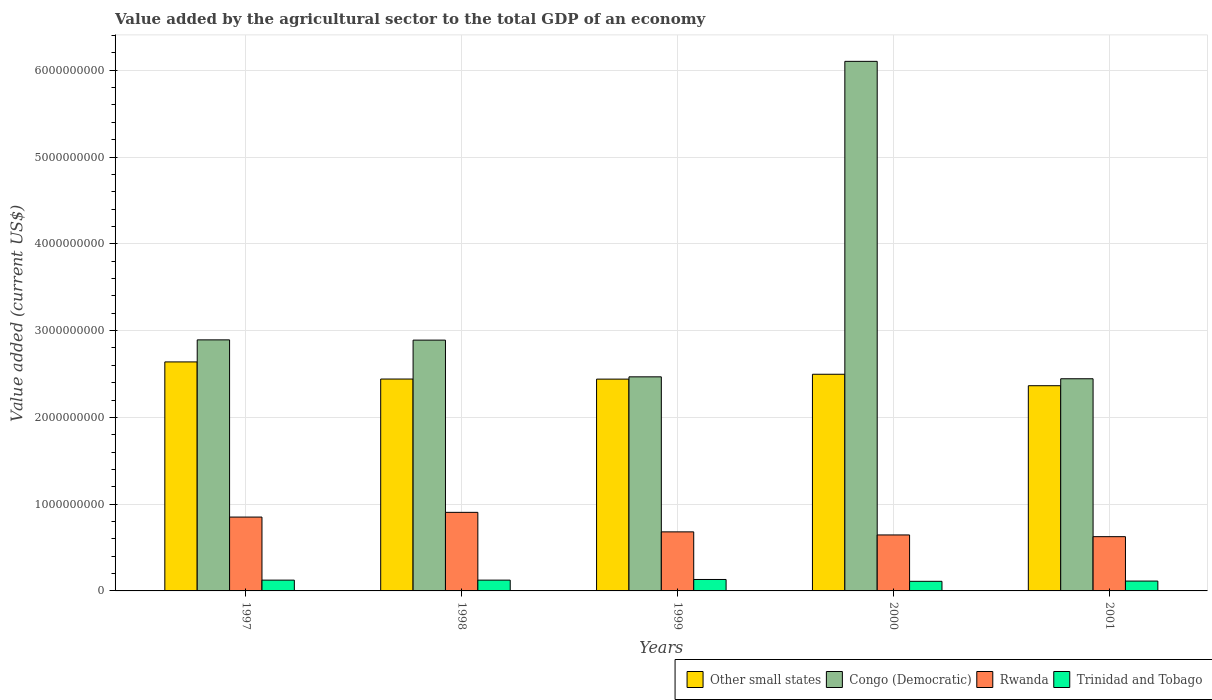How many groups of bars are there?
Offer a terse response. 5. Are the number of bars on each tick of the X-axis equal?
Your response must be concise. Yes. How many bars are there on the 3rd tick from the left?
Your response must be concise. 4. How many bars are there on the 4th tick from the right?
Keep it short and to the point. 4. What is the label of the 1st group of bars from the left?
Your response must be concise. 1997. In how many cases, is the number of bars for a given year not equal to the number of legend labels?
Make the answer very short. 0. What is the value added by the agricultural sector to the total GDP in Congo (Democratic) in 1997?
Your answer should be very brief. 2.89e+09. Across all years, what is the maximum value added by the agricultural sector to the total GDP in Congo (Democratic)?
Your response must be concise. 6.10e+09. Across all years, what is the minimum value added by the agricultural sector to the total GDP in Other small states?
Offer a terse response. 2.36e+09. In which year was the value added by the agricultural sector to the total GDP in Other small states maximum?
Keep it short and to the point. 1997. In which year was the value added by the agricultural sector to the total GDP in Congo (Democratic) minimum?
Your answer should be very brief. 2001. What is the total value added by the agricultural sector to the total GDP in Congo (Democratic) in the graph?
Provide a succinct answer. 1.68e+1. What is the difference between the value added by the agricultural sector to the total GDP in Trinidad and Tobago in 1998 and that in 2001?
Offer a very short reply. 1.09e+07. What is the difference between the value added by the agricultural sector to the total GDP in Trinidad and Tobago in 1998 and the value added by the agricultural sector to the total GDP in Other small states in 2001?
Offer a very short reply. -2.24e+09. What is the average value added by the agricultural sector to the total GDP in Congo (Democratic) per year?
Make the answer very short. 3.36e+09. In the year 1999, what is the difference between the value added by the agricultural sector to the total GDP in Trinidad and Tobago and value added by the agricultural sector to the total GDP in Other small states?
Ensure brevity in your answer.  -2.31e+09. In how many years, is the value added by the agricultural sector to the total GDP in Other small states greater than 1800000000 US$?
Your response must be concise. 5. What is the ratio of the value added by the agricultural sector to the total GDP in Congo (Democratic) in 1997 to that in 2000?
Your answer should be compact. 0.47. Is the difference between the value added by the agricultural sector to the total GDP in Trinidad and Tobago in 1997 and 1999 greater than the difference between the value added by the agricultural sector to the total GDP in Other small states in 1997 and 1999?
Offer a terse response. No. What is the difference between the highest and the second highest value added by the agricultural sector to the total GDP in Congo (Democratic)?
Ensure brevity in your answer.  3.21e+09. What is the difference between the highest and the lowest value added by the agricultural sector to the total GDP in Rwanda?
Provide a short and direct response. 2.80e+08. Is it the case that in every year, the sum of the value added by the agricultural sector to the total GDP in Trinidad and Tobago and value added by the agricultural sector to the total GDP in Congo (Democratic) is greater than the sum of value added by the agricultural sector to the total GDP in Rwanda and value added by the agricultural sector to the total GDP in Other small states?
Make the answer very short. No. What does the 1st bar from the left in 2001 represents?
Provide a succinct answer. Other small states. What does the 1st bar from the right in 1999 represents?
Your answer should be compact. Trinidad and Tobago. How many bars are there?
Offer a terse response. 20. Are all the bars in the graph horizontal?
Make the answer very short. No. How many years are there in the graph?
Your response must be concise. 5. Does the graph contain any zero values?
Keep it short and to the point. No. Where does the legend appear in the graph?
Provide a succinct answer. Bottom right. How many legend labels are there?
Make the answer very short. 4. What is the title of the graph?
Ensure brevity in your answer.  Value added by the agricultural sector to the total GDP of an economy. What is the label or title of the X-axis?
Provide a succinct answer. Years. What is the label or title of the Y-axis?
Offer a terse response. Value added (current US$). What is the Value added (current US$) in Other small states in 1997?
Offer a very short reply. 2.64e+09. What is the Value added (current US$) in Congo (Democratic) in 1997?
Your answer should be compact. 2.89e+09. What is the Value added (current US$) in Rwanda in 1997?
Your answer should be compact. 8.51e+08. What is the Value added (current US$) in Trinidad and Tobago in 1997?
Make the answer very short. 1.24e+08. What is the Value added (current US$) of Other small states in 1998?
Your answer should be very brief. 2.44e+09. What is the Value added (current US$) in Congo (Democratic) in 1998?
Your response must be concise. 2.89e+09. What is the Value added (current US$) in Rwanda in 1998?
Provide a short and direct response. 9.05e+08. What is the Value added (current US$) in Trinidad and Tobago in 1998?
Make the answer very short. 1.24e+08. What is the Value added (current US$) in Other small states in 1999?
Offer a very short reply. 2.44e+09. What is the Value added (current US$) in Congo (Democratic) in 1999?
Ensure brevity in your answer.  2.47e+09. What is the Value added (current US$) in Rwanda in 1999?
Provide a succinct answer. 6.80e+08. What is the Value added (current US$) in Trinidad and Tobago in 1999?
Ensure brevity in your answer.  1.32e+08. What is the Value added (current US$) of Other small states in 2000?
Provide a short and direct response. 2.50e+09. What is the Value added (current US$) of Congo (Democratic) in 2000?
Keep it short and to the point. 6.10e+09. What is the Value added (current US$) of Rwanda in 2000?
Offer a very short reply. 6.45e+08. What is the Value added (current US$) in Trinidad and Tobago in 2000?
Make the answer very short. 1.11e+08. What is the Value added (current US$) of Other small states in 2001?
Make the answer very short. 2.36e+09. What is the Value added (current US$) of Congo (Democratic) in 2001?
Give a very brief answer. 2.44e+09. What is the Value added (current US$) of Rwanda in 2001?
Your answer should be very brief. 6.25e+08. What is the Value added (current US$) in Trinidad and Tobago in 2001?
Ensure brevity in your answer.  1.14e+08. Across all years, what is the maximum Value added (current US$) of Other small states?
Make the answer very short. 2.64e+09. Across all years, what is the maximum Value added (current US$) of Congo (Democratic)?
Your response must be concise. 6.10e+09. Across all years, what is the maximum Value added (current US$) in Rwanda?
Your answer should be very brief. 9.05e+08. Across all years, what is the maximum Value added (current US$) of Trinidad and Tobago?
Your response must be concise. 1.32e+08. Across all years, what is the minimum Value added (current US$) in Other small states?
Offer a terse response. 2.36e+09. Across all years, what is the minimum Value added (current US$) of Congo (Democratic)?
Keep it short and to the point. 2.44e+09. Across all years, what is the minimum Value added (current US$) in Rwanda?
Your answer should be compact. 6.25e+08. Across all years, what is the minimum Value added (current US$) of Trinidad and Tobago?
Your response must be concise. 1.11e+08. What is the total Value added (current US$) in Other small states in the graph?
Your answer should be compact. 1.24e+1. What is the total Value added (current US$) of Congo (Democratic) in the graph?
Give a very brief answer. 1.68e+1. What is the total Value added (current US$) in Rwanda in the graph?
Give a very brief answer. 3.71e+09. What is the total Value added (current US$) of Trinidad and Tobago in the graph?
Provide a short and direct response. 6.05e+08. What is the difference between the Value added (current US$) of Other small states in 1997 and that in 1998?
Offer a very short reply. 1.97e+08. What is the difference between the Value added (current US$) in Congo (Democratic) in 1997 and that in 1998?
Offer a very short reply. 2.95e+06. What is the difference between the Value added (current US$) in Rwanda in 1997 and that in 1998?
Provide a succinct answer. -5.45e+07. What is the difference between the Value added (current US$) in Trinidad and Tobago in 1997 and that in 1998?
Give a very brief answer. -3.26e+04. What is the difference between the Value added (current US$) of Other small states in 1997 and that in 1999?
Offer a terse response. 1.98e+08. What is the difference between the Value added (current US$) in Congo (Democratic) in 1997 and that in 1999?
Keep it short and to the point. 4.26e+08. What is the difference between the Value added (current US$) of Rwanda in 1997 and that in 1999?
Make the answer very short. 1.71e+08. What is the difference between the Value added (current US$) of Trinidad and Tobago in 1997 and that in 1999?
Ensure brevity in your answer.  -7.47e+06. What is the difference between the Value added (current US$) in Other small states in 1997 and that in 2000?
Provide a succinct answer. 1.42e+08. What is the difference between the Value added (current US$) in Congo (Democratic) in 1997 and that in 2000?
Give a very brief answer. -3.21e+09. What is the difference between the Value added (current US$) in Rwanda in 1997 and that in 2000?
Ensure brevity in your answer.  2.06e+08. What is the difference between the Value added (current US$) in Trinidad and Tobago in 1997 and that in 2000?
Keep it short and to the point. 1.37e+07. What is the difference between the Value added (current US$) of Other small states in 1997 and that in 2001?
Keep it short and to the point. 2.74e+08. What is the difference between the Value added (current US$) in Congo (Democratic) in 1997 and that in 2001?
Make the answer very short. 4.48e+08. What is the difference between the Value added (current US$) of Rwanda in 1997 and that in 2001?
Offer a terse response. 2.26e+08. What is the difference between the Value added (current US$) of Trinidad and Tobago in 1997 and that in 2001?
Offer a terse response. 1.08e+07. What is the difference between the Value added (current US$) in Other small states in 1998 and that in 1999?
Provide a succinct answer. 9.06e+05. What is the difference between the Value added (current US$) in Congo (Democratic) in 1998 and that in 1999?
Your answer should be compact. 4.23e+08. What is the difference between the Value added (current US$) of Rwanda in 1998 and that in 1999?
Offer a very short reply. 2.25e+08. What is the difference between the Value added (current US$) of Trinidad and Tobago in 1998 and that in 1999?
Give a very brief answer. -7.43e+06. What is the difference between the Value added (current US$) of Other small states in 1998 and that in 2000?
Offer a terse response. -5.51e+07. What is the difference between the Value added (current US$) of Congo (Democratic) in 1998 and that in 2000?
Your response must be concise. -3.21e+09. What is the difference between the Value added (current US$) of Rwanda in 1998 and that in 2000?
Offer a terse response. 2.60e+08. What is the difference between the Value added (current US$) of Trinidad and Tobago in 1998 and that in 2000?
Give a very brief answer. 1.37e+07. What is the difference between the Value added (current US$) in Other small states in 1998 and that in 2001?
Provide a short and direct response. 7.70e+07. What is the difference between the Value added (current US$) of Congo (Democratic) in 1998 and that in 2001?
Your response must be concise. 4.45e+08. What is the difference between the Value added (current US$) of Rwanda in 1998 and that in 2001?
Offer a terse response. 2.80e+08. What is the difference between the Value added (current US$) of Trinidad and Tobago in 1998 and that in 2001?
Your answer should be compact. 1.09e+07. What is the difference between the Value added (current US$) in Other small states in 1999 and that in 2000?
Your response must be concise. -5.60e+07. What is the difference between the Value added (current US$) in Congo (Democratic) in 1999 and that in 2000?
Offer a very short reply. -3.64e+09. What is the difference between the Value added (current US$) of Rwanda in 1999 and that in 2000?
Give a very brief answer. 3.53e+07. What is the difference between the Value added (current US$) in Trinidad and Tobago in 1999 and that in 2000?
Your answer should be compact. 2.11e+07. What is the difference between the Value added (current US$) of Other small states in 1999 and that in 2001?
Your answer should be very brief. 7.61e+07. What is the difference between the Value added (current US$) of Congo (Democratic) in 1999 and that in 2001?
Offer a terse response. 2.21e+07. What is the difference between the Value added (current US$) in Rwanda in 1999 and that in 2001?
Ensure brevity in your answer.  5.52e+07. What is the difference between the Value added (current US$) in Trinidad and Tobago in 1999 and that in 2001?
Offer a terse response. 1.83e+07. What is the difference between the Value added (current US$) in Other small states in 2000 and that in 2001?
Your answer should be compact. 1.32e+08. What is the difference between the Value added (current US$) of Congo (Democratic) in 2000 and that in 2001?
Give a very brief answer. 3.66e+09. What is the difference between the Value added (current US$) in Rwanda in 2000 and that in 2001?
Your answer should be very brief. 1.99e+07. What is the difference between the Value added (current US$) in Trinidad and Tobago in 2000 and that in 2001?
Offer a very short reply. -2.83e+06. What is the difference between the Value added (current US$) in Other small states in 1997 and the Value added (current US$) in Congo (Democratic) in 1998?
Keep it short and to the point. -2.51e+08. What is the difference between the Value added (current US$) in Other small states in 1997 and the Value added (current US$) in Rwanda in 1998?
Ensure brevity in your answer.  1.73e+09. What is the difference between the Value added (current US$) of Other small states in 1997 and the Value added (current US$) of Trinidad and Tobago in 1998?
Give a very brief answer. 2.51e+09. What is the difference between the Value added (current US$) in Congo (Democratic) in 1997 and the Value added (current US$) in Rwanda in 1998?
Your response must be concise. 1.99e+09. What is the difference between the Value added (current US$) of Congo (Democratic) in 1997 and the Value added (current US$) of Trinidad and Tobago in 1998?
Your response must be concise. 2.77e+09. What is the difference between the Value added (current US$) in Rwanda in 1997 and the Value added (current US$) in Trinidad and Tobago in 1998?
Give a very brief answer. 7.27e+08. What is the difference between the Value added (current US$) of Other small states in 1997 and the Value added (current US$) of Congo (Democratic) in 1999?
Keep it short and to the point. 1.72e+08. What is the difference between the Value added (current US$) of Other small states in 1997 and the Value added (current US$) of Rwanda in 1999?
Give a very brief answer. 1.96e+09. What is the difference between the Value added (current US$) of Other small states in 1997 and the Value added (current US$) of Trinidad and Tobago in 1999?
Keep it short and to the point. 2.51e+09. What is the difference between the Value added (current US$) in Congo (Democratic) in 1997 and the Value added (current US$) in Rwanda in 1999?
Give a very brief answer. 2.21e+09. What is the difference between the Value added (current US$) in Congo (Democratic) in 1997 and the Value added (current US$) in Trinidad and Tobago in 1999?
Offer a very short reply. 2.76e+09. What is the difference between the Value added (current US$) in Rwanda in 1997 and the Value added (current US$) in Trinidad and Tobago in 1999?
Make the answer very short. 7.19e+08. What is the difference between the Value added (current US$) in Other small states in 1997 and the Value added (current US$) in Congo (Democratic) in 2000?
Make the answer very short. -3.46e+09. What is the difference between the Value added (current US$) in Other small states in 1997 and the Value added (current US$) in Rwanda in 2000?
Offer a terse response. 1.99e+09. What is the difference between the Value added (current US$) in Other small states in 1997 and the Value added (current US$) in Trinidad and Tobago in 2000?
Your answer should be very brief. 2.53e+09. What is the difference between the Value added (current US$) of Congo (Democratic) in 1997 and the Value added (current US$) of Rwanda in 2000?
Your answer should be compact. 2.25e+09. What is the difference between the Value added (current US$) in Congo (Democratic) in 1997 and the Value added (current US$) in Trinidad and Tobago in 2000?
Your answer should be very brief. 2.78e+09. What is the difference between the Value added (current US$) in Rwanda in 1997 and the Value added (current US$) in Trinidad and Tobago in 2000?
Your answer should be compact. 7.40e+08. What is the difference between the Value added (current US$) of Other small states in 1997 and the Value added (current US$) of Congo (Democratic) in 2001?
Keep it short and to the point. 1.94e+08. What is the difference between the Value added (current US$) in Other small states in 1997 and the Value added (current US$) in Rwanda in 2001?
Provide a succinct answer. 2.01e+09. What is the difference between the Value added (current US$) in Other small states in 1997 and the Value added (current US$) in Trinidad and Tobago in 2001?
Your answer should be very brief. 2.53e+09. What is the difference between the Value added (current US$) of Congo (Democratic) in 1997 and the Value added (current US$) of Rwanda in 2001?
Keep it short and to the point. 2.27e+09. What is the difference between the Value added (current US$) of Congo (Democratic) in 1997 and the Value added (current US$) of Trinidad and Tobago in 2001?
Provide a short and direct response. 2.78e+09. What is the difference between the Value added (current US$) in Rwanda in 1997 and the Value added (current US$) in Trinidad and Tobago in 2001?
Keep it short and to the point. 7.37e+08. What is the difference between the Value added (current US$) in Other small states in 1998 and the Value added (current US$) in Congo (Democratic) in 1999?
Your answer should be compact. -2.52e+07. What is the difference between the Value added (current US$) of Other small states in 1998 and the Value added (current US$) of Rwanda in 1999?
Keep it short and to the point. 1.76e+09. What is the difference between the Value added (current US$) in Other small states in 1998 and the Value added (current US$) in Trinidad and Tobago in 1999?
Ensure brevity in your answer.  2.31e+09. What is the difference between the Value added (current US$) in Congo (Democratic) in 1998 and the Value added (current US$) in Rwanda in 1999?
Your response must be concise. 2.21e+09. What is the difference between the Value added (current US$) in Congo (Democratic) in 1998 and the Value added (current US$) in Trinidad and Tobago in 1999?
Offer a very short reply. 2.76e+09. What is the difference between the Value added (current US$) in Rwanda in 1998 and the Value added (current US$) in Trinidad and Tobago in 1999?
Your answer should be very brief. 7.74e+08. What is the difference between the Value added (current US$) in Other small states in 1998 and the Value added (current US$) in Congo (Democratic) in 2000?
Your answer should be very brief. -3.66e+09. What is the difference between the Value added (current US$) of Other small states in 1998 and the Value added (current US$) of Rwanda in 2000?
Your response must be concise. 1.80e+09. What is the difference between the Value added (current US$) of Other small states in 1998 and the Value added (current US$) of Trinidad and Tobago in 2000?
Give a very brief answer. 2.33e+09. What is the difference between the Value added (current US$) of Congo (Democratic) in 1998 and the Value added (current US$) of Rwanda in 2000?
Provide a succinct answer. 2.25e+09. What is the difference between the Value added (current US$) of Congo (Democratic) in 1998 and the Value added (current US$) of Trinidad and Tobago in 2000?
Offer a terse response. 2.78e+09. What is the difference between the Value added (current US$) of Rwanda in 1998 and the Value added (current US$) of Trinidad and Tobago in 2000?
Offer a terse response. 7.95e+08. What is the difference between the Value added (current US$) of Other small states in 1998 and the Value added (current US$) of Congo (Democratic) in 2001?
Your answer should be very brief. -3.13e+06. What is the difference between the Value added (current US$) in Other small states in 1998 and the Value added (current US$) in Rwanda in 2001?
Your answer should be compact. 1.82e+09. What is the difference between the Value added (current US$) in Other small states in 1998 and the Value added (current US$) in Trinidad and Tobago in 2001?
Your answer should be very brief. 2.33e+09. What is the difference between the Value added (current US$) of Congo (Democratic) in 1998 and the Value added (current US$) of Rwanda in 2001?
Give a very brief answer. 2.27e+09. What is the difference between the Value added (current US$) in Congo (Democratic) in 1998 and the Value added (current US$) in Trinidad and Tobago in 2001?
Your answer should be very brief. 2.78e+09. What is the difference between the Value added (current US$) in Rwanda in 1998 and the Value added (current US$) in Trinidad and Tobago in 2001?
Offer a terse response. 7.92e+08. What is the difference between the Value added (current US$) in Other small states in 1999 and the Value added (current US$) in Congo (Democratic) in 2000?
Your answer should be compact. -3.66e+09. What is the difference between the Value added (current US$) in Other small states in 1999 and the Value added (current US$) in Rwanda in 2000?
Offer a very short reply. 1.80e+09. What is the difference between the Value added (current US$) in Other small states in 1999 and the Value added (current US$) in Trinidad and Tobago in 2000?
Keep it short and to the point. 2.33e+09. What is the difference between the Value added (current US$) of Congo (Democratic) in 1999 and the Value added (current US$) of Rwanda in 2000?
Your answer should be very brief. 1.82e+09. What is the difference between the Value added (current US$) of Congo (Democratic) in 1999 and the Value added (current US$) of Trinidad and Tobago in 2000?
Your response must be concise. 2.36e+09. What is the difference between the Value added (current US$) of Rwanda in 1999 and the Value added (current US$) of Trinidad and Tobago in 2000?
Offer a terse response. 5.70e+08. What is the difference between the Value added (current US$) in Other small states in 1999 and the Value added (current US$) in Congo (Democratic) in 2001?
Provide a succinct answer. -4.04e+06. What is the difference between the Value added (current US$) in Other small states in 1999 and the Value added (current US$) in Rwanda in 2001?
Make the answer very short. 1.82e+09. What is the difference between the Value added (current US$) of Other small states in 1999 and the Value added (current US$) of Trinidad and Tobago in 2001?
Provide a short and direct response. 2.33e+09. What is the difference between the Value added (current US$) in Congo (Democratic) in 1999 and the Value added (current US$) in Rwanda in 2001?
Offer a terse response. 1.84e+09. What is the difference between the Value added (current US$) in Congo (Democratic) in 1999 and the Value added (current US$) in Trinidad and Tobago in 2001?
Your answer should be compact. 2.35e+09. What is the difference between the Value added (current US$) of Rwanda in 1999 and the Value added (current US$) of Trinidad and Tobago in 2001?
Give a very brief answer. 5.67e+08. What is the difference between the Value added (current US$) of Other small states in 2000 and the Value added (current US$) of Congo (Democratic) in 2001?
Your response must be concise. 5.19e+07. What is the difference between the Value added (current US$) of Other small states in 2000 and the Value added (current US$) of Rwanda in 2001?
Make the answer very short. 1.87e+09. What is the difference between the Value added (current US$) of Other small states in 2000 and the Value added (current US$) of Trinidad and Tobago in 2001?
Keep it short and to the point. 2.38e+09. What is the difference between the Value added (current US$) in Congo (Democratic) in 2000 and the Value added (current US$) in Rwanda in 2001?
Offer a very short reply. 5.48e+09. What is the difference between the Value added (current US$) in Congo (Democratic) in 2000 and the Value added (current US$) in Trinidad and Tobago in 2001?
Provide a short and direct response. 5.99e+09. What is the difference between the Value added (current US$) of Rwanda in 2000 and the Value added (current US$) of Trinidad and Tobago in 2001?
Your answer should be compact. 5.32e+08. What is the average Value added (current US$) of Other small states per year?
Provide a short and direct response. 2.48e+09. What is the average Value added (current US$) in Congo (Democratic) per year?
Your answer should be very brief. 3.36e+09. What is the average Value added (current US$) in Rwanda per year?
Your answer should be compact. 7.41e+08. What is the average Value added (current US$) in Trinidad and Tobago per year?
Provide a short and direct response. 1.21e+08. In the year 1997, what is the difference between the Value added (current US$) of Other small states and Value added (current US$) of Congo (Democratic)?
Give a very brief answer. -2.54e+08. In the year 1997, what is the difference between the Value added (current US$) in Other small states and Value added (current US$) in Rwanda?
Make the answer very short. 1.79e+09. In the year 1997, what is the difference between the Value added (current US$) of Other small states and Value added (current US$) of Trinidad and Tobago?
Provide a short and direct response. 2.51e+09. In the year 1997, what is the difference between the Value added (current US$) in Congo (Democratic) and Value added (current US$) in Rwanda?
Your answer should be very brief. 2.04e+09. In the year 1997, what is the difference between the Value added (current US$) of Congo (Democratic) and Value added (current US$) of Trinidad and Tobago?
Provide a short and direct response. 2.77e+09. In the year 1997, what is the difference between the Value added (current US$) of Rwanda and Value added (current US$) of Trinidad and Tobago?
Your response must be concise. 7.27e+08. In the year 1998, what is the difference between the Value added (current US$) in Other small states and Value added (current US$) in Congo (Democratic)?
Your answer should be very brief. -4.48e+08. In the year 1998, what is the difference between the Value added (current US$) of Other small states and Value added (current US$) of Rwanda?
Your answer should be very brief. 1.54e+09. In the year 1998, what is the difference between the Value added (current US$) of Other small states and Value added (current US$) of Trinidad and Tobago?
Ensure brevity in your answer.  2.32e+09. In the year 1998, what is the difference between the Value added (current US$) in Congo (Democratic) and Value added (current US$) in Rwanda?
Keep it short and to the point. 1.98e+09. In the year 1998, what is the difference between the Value added (current US$) of Congo (Democratic) and Value added (current US$) of Trinidad and Tobago?
Your answer should be very brief. 2.77e+09. In the year 1998, what is the difference between the Value added (current US$) of Rwanda and Value added (current US$) of Trinidad and Tobago?
Offer a very short reply. 7.81e+08. In the year 1999, what is the difference between the Value added (current US$) in Other small states and Value added (current US$) in Congo (Democratic)?
Provide a succinct answer. -2.61e+07. In the year 1999, what is the difference between the Value added (current US$) of Other small states and Value added (current US$) of Rwanda?
Make the answer very short. 1.76e+09. In the year 1999, what is the difference between the Value added (current US$) in Other small states and Value added (current US$) in Trinidad and Tobago?
Provide a succinct answer. 2.31e+09. In the year 1999, what is the difference between the Value added (current US$) of Congo (Democratic) and Value added (current US$) of Rwanda?
Ensure brevity in your answer.  1.79e+09. In the year 1999, what is the difference between the Value added (current US$) of Congo (Democratic) and Value added (current US$) of Trinidad and Tobago?
Your answer should be very brief. 2.34e+09. In the year 1999, what is the difference between the Value added (current US$) of Rwanda and Value added (current US$) of Trinidad and Tobago?
Give a very brief answer. 5.49e+08. In the year 2000, what is the difference between the Value added (current US$) of Other small states and Value added (current US$) of Congo (Democratic)?
Make the answer very short. -3.61e+09. In the year 2000, what is the difference between the Value added (current US$) of Other small states and Value added (current US$) of Rwanda?
Ensure brevity in your answer.  1.85e+09. In the year 2000, what is the difference between the Value added (current US$) of Other small states and Value added (current US$) of Trinidad and Tobago?
Provide a short and direct response. 2.39e+09. In the year 2000, what is the difference between the Value added (current US$) in Congo (Democratic) and Value added (current US$) in Rwanda?
Give a very brief answer. 5.46e+09. In the year 2000, what is the difference between the Value added (current US$) in Congo (Democratic) and Value added (current US$) in Trinidad and Tobago?
Your response must be concise. 5.99e+09. In the year 2000, what is the difference between the Value added (current US$) of Rwanda and Value added (current US$) of Trinidad and Tobago?
Your answer should be very brief. 5.34e+08. In the year 2001, what is the difference between the Value added (current US$) in Other small states and Value added (current US$) in Congo (Democratic)?
Make the answer very short. -8.02e+07. In the year 2001, what is the difference between the Value added (current US$) of Other small states and Value added (current US$) of Rwanda?
Make the answer very short. 1.74e+09. In the year 2001, what is the difference between the Value added (current US$) in Other small states and Value added (current US$) in Trinidad and Tobago?
Offer a very short reply. 2.25e+09. In the year 2001, what is the difference between the Value added (current US$) in Congo (Democratic) and Value added (current US$) in Rwanda?
Offer a terse response. 1.82e+09. In the year 2001, what is the difference between the Value added (current US$) of Congo (Democratic) and Value added (current US$) of Trinidad and Tobago?
Your answer should be very brief. 2.33e+09. In the year 2001, what is the difference between the Value added (current US$) in Rwanda and Value added (current US$) in Trinidad and Tobago?
Your response must be concise. 5.12e+08. What is the ratio of the Value added (current US$) of Other small states in 1997 to that in 1998?
Make the answer very short. 1.08. What is the ratio of the Value added (current US$) in Rwanda in 1997 to that in 1998?
Your answer should be compact. 0.94. What is the ratio of the Value added (current US$) of Other small states in 1997 to that in 1999?
Provide a succinct answer. 1.08. What is the ratio of the Value added (current US$) of Congo (Democratic) in 1997 to that in 1999?
Give a very brief answer. 1.17. What is the ratio of the Value added (current US$) in Rwanda in 1997 to that in 1999?
Offer a terse response. 1.25. What is the ratio of the Value added (current US$) in Trinidad and Tobago in 1997 to that in 1999?
Your answer should be very brief. 0.94. What is the ratio of the Value added (current US$) of Other small states in 1997 to that in 2000?
Offer a very short reply. 1.06. What is the ratio of the Value added (current US$) in Congo (Democratic) in 1997 to that in 2000?
Ensure brevity in your answer.  0.47. What is the ratio of the Value added (current US$) in Rwanda in 1997 to that in 2000?
Ensure brevity in your answer.  1.32. What is the ratio of the Value added (current US$) of Trinidad and Tobago in 1997 to that in 2000?
Make the answer very short. 1.12. What is the ratio of the Value added (current US$) in Other small states in 1997 to that in 2001?
Your answer should be very brief. 1.12. What is the ratio of the Value added (current US$) in Congo (Democratic) in 1997 to that in 2001?
Provide a short and direct response. 1.18. What is the ratio of the Value added (current US$) in Rwanda in 1997 to that in 2001?
Keep it short and to the point. 1.36. What is the ratio of the Value added (current US$) of Trinidad and Tobago in 1997 to that in 2001?
Provide a short and direct response. 1.1. What is the ratio of the Value added (current US$) of Other small states in 1998 to that in 1999?
Offer a very short reply. 1. What is the ratio of the Value added (current US$) of Congo (Democratic) in 1998 to that in 1999?
Your answer should be very brief. 1.17. What is the ratio of the Value added (current US$) of Rwanda in 1998 to that in 1999?
Your response must be concise. 1.33. What is the ratio of the Value added (current US$) in Trinidad and Tobago in 1998 to that in 1999?
Your answer should be compact. 0.94. What is the ratio of the Value added (current US$) in Other small states in 1998 to that in 2000?
Keep it short and to the point. 0.98. What is the ratio of the Value added (current US$) in Congo (Democratic) in 1998 to that in 2000?
Provide a short and direct response. 0.47. What is the ratio of the Value added (current US$) of Rwanda in 1998 to that in 2000?
Ensure brevity in your answer.  1.4. What is the ratio of the Value added (current US$) in Trinidad and Tobago in 1998 to that in 2000?
Your answer should be compact. 1.12. What is the ratio of the Value added (current US$) of Other small states in 1998 to that in 2001?
Make the answer very short. 1.03. What is the ratio of the Value added (current US$) in Congo (Democratic) in 1998 to that in 2001?
Keep it short and to the point. 1.18. What is the ratio of the Value added (current US$) of Rwanda in 1998 to that in 2001?
Ensure brevity in your answer.  1.45. What is the ratio of the Value added (current US$) of Trinidad and Tobago in 1998 to that in 2001?
Ensure brevity in your answer.  1.1. What is the ratio of the Value added (current US$) in Other small states in 1999 to that in 2000?
Keep it short and to the point. 0.98. What is the ratio of the Value added (current US$) of Congo (Democratic) in 1999 to that in 2000?
Your answer should be compact. 0.4. What is the ratio of the Value added (current US$) of Rwanda in 1999 to that in 2000?
Your answer should be very brief. 1.05. What is the ratio of the Value added (current US$) of Trinidad and Tobago in 1999 to that in 2000?
Your answer should be very brief. 1.19. What is the ratio of the Value added (current US$) in Other small states in 1999 to that in 2001?
Provide a short and direct response. 1.03. What is the ratio of the Value added (current US$) of Rwanda in 1999 to that in 2001?
Offer a very short reply. 1.09. What is the ratio of the Value added (current US$) in Trinidad and Tobago in 1999 to that in 2001?
Make the answer very short. 1.16. What is the ratio of the Value added (current US$) of Other small states in 2000 to that in 2001?
Provide a short and direct response. 1.06. What is the ratio of the Value added (current US$) in Congo (Democratic) in 2000 to that in 2001?
Ensure brevity in your answer.  2.5. What is the ratio of the Value added (current US$) in Rwanda in 2000 to that in 2001?
Make the answer very short. 1.03. What is the ratio of the Value added (current US$) in Trinidad and Tobago in 2000 to that in 2001?
Offer a very short reply. 0.97. What is the difference between the highest and the second highest Value added (current US$) in Other small states?
Provide a succinct answer. 1.42e+08. What is the difference between the highest and the second highest Value added (current US$) of Congo (Democratic)?
Give a very brief answer. 3.21e+09. What is the difference between the highest and the second highest Value added (current US$) of Rwanda?
Provide a short and direct response. 5.45e+07. What is the difference between the highest and the second highest Value added (current US$) in Trinidad and Tobago?
Offer a very short reply. 7.43e+06. What is the difference between the highest and the lowest Value added (current US$) of Other small states?
Offer a terse response. 2.74e+08. What is the difference between the highest and the lowest Value added (current US$) in Congo (Democratic)?
Make the answer very short. 3.66e+09. What is the difference between the highest and the lowest Value added (current US$) of Rwanda?
Provide a short and direct response. 2.80e+08. What is the difference between the highest and the lowest Value added (current US$) of Trinidad and Tobago?
Offer a very short reply. 2.11e+07. 